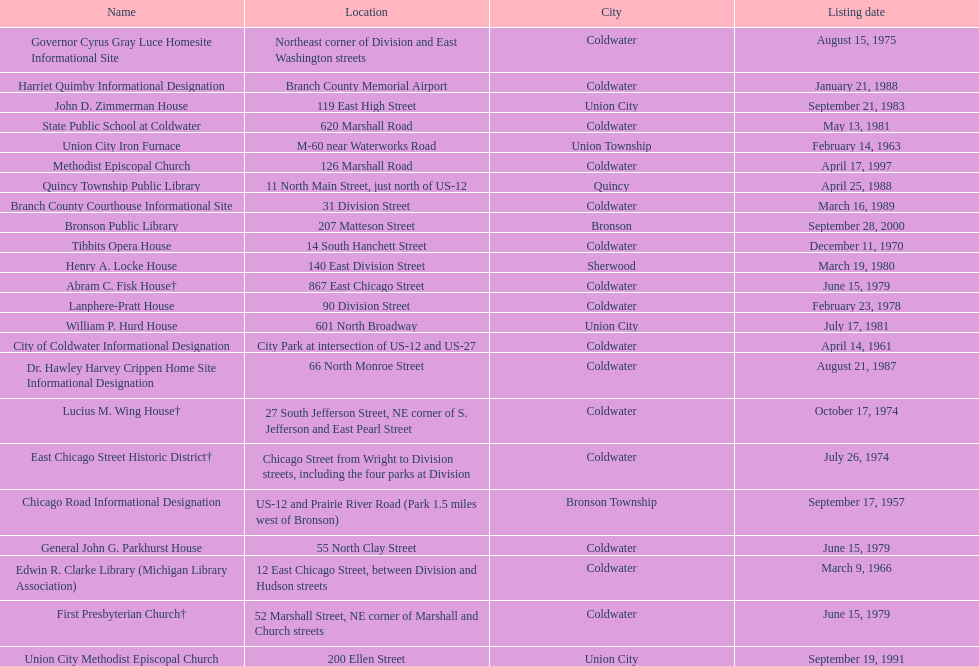How many historic sites are listed in coldwater? 15. 